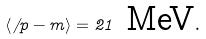<formula> <loc_0><loc_0><loc_500><loc_500>\langle \not \, p - m \rangle = 2 1 \ \text {MeV} .</formula> 